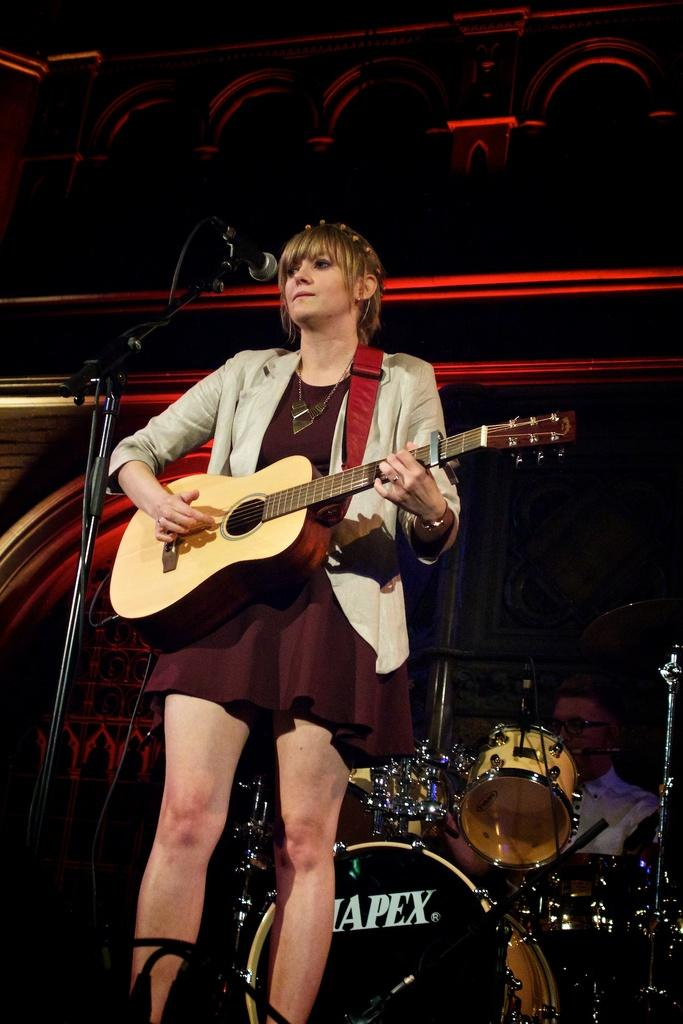Who is the main subject in the image? There is a woman in the image. What is the woman doing in the image? The woman is standing in front of a mic and holding a guitar. Can you describe the man in the background of the image? The man is near to the drums in the background of the image. What type of industry is depicted in the image? There is no industry depicted in the image; it features a woman with a guitar and a man near drums. How many dimes can be seen on the edge of the mic in the image? There are no dimes present in the image. 